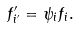<formula> <loc_0><loc_0><loc_500><loc_500>f ^ { \prime } _ { i ^ { \prime } } = \psi _ { i } f _ { i } .</formula> 